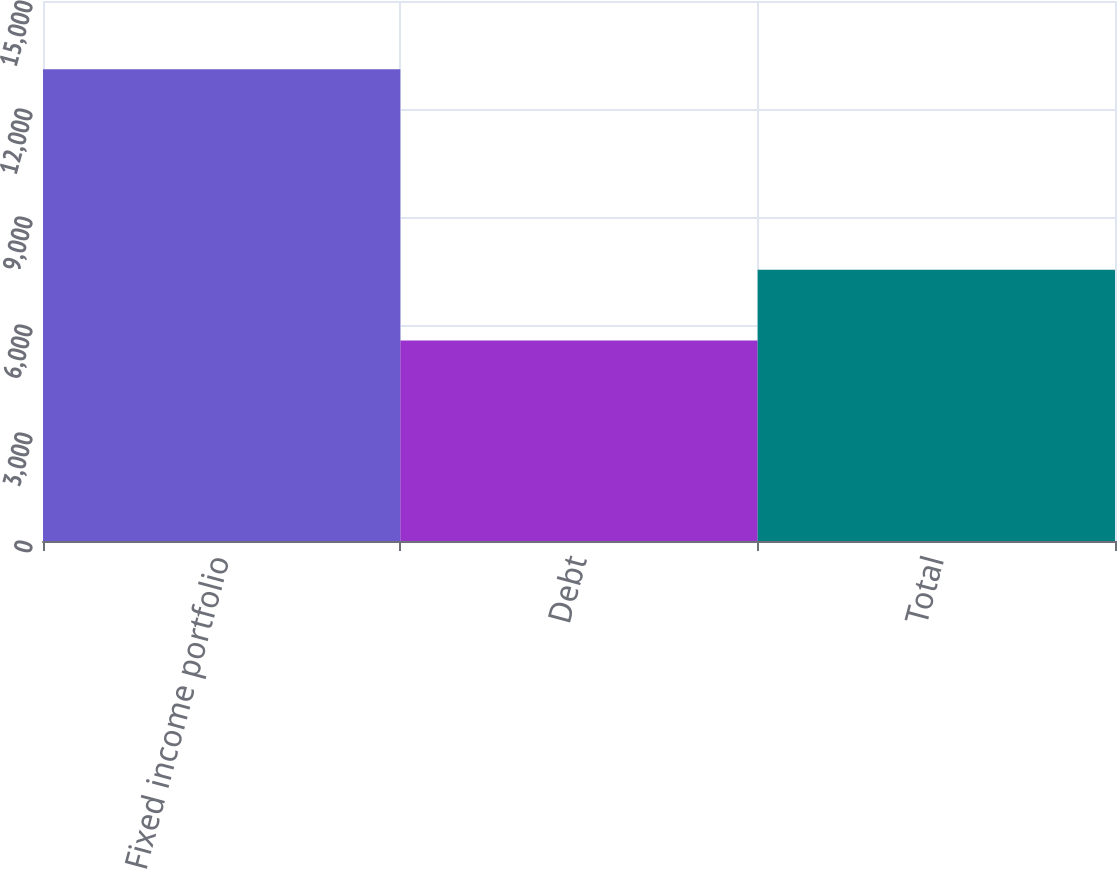<chart> <loc_0><loc_0><loc_500><loc_500><bar_chart><fcel>Fixed income portfolio<fcel>Debt<fcel>Total<nl><fcel>13105<fcel>5567<fcel>7538<nl></chart> 